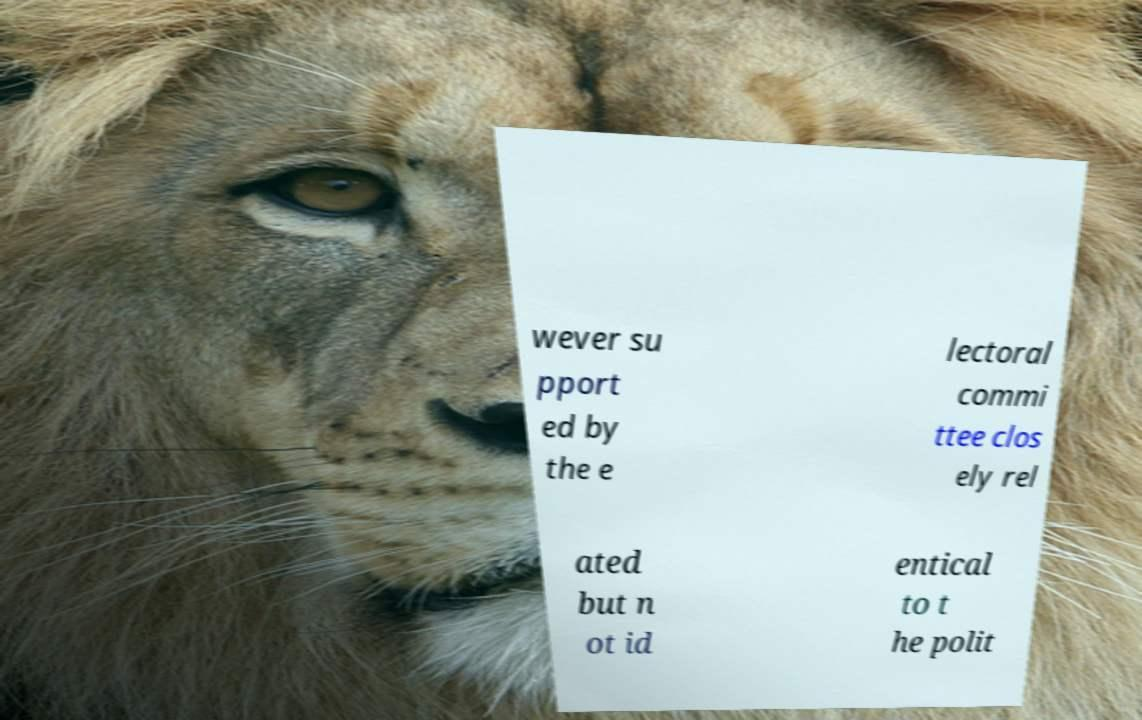Could you assist in decoding the text presented in this image and type it out clearly? wever su pport ed by the e lectoral commi ttee clos ely rel ated but n ot id entical to t he polit 